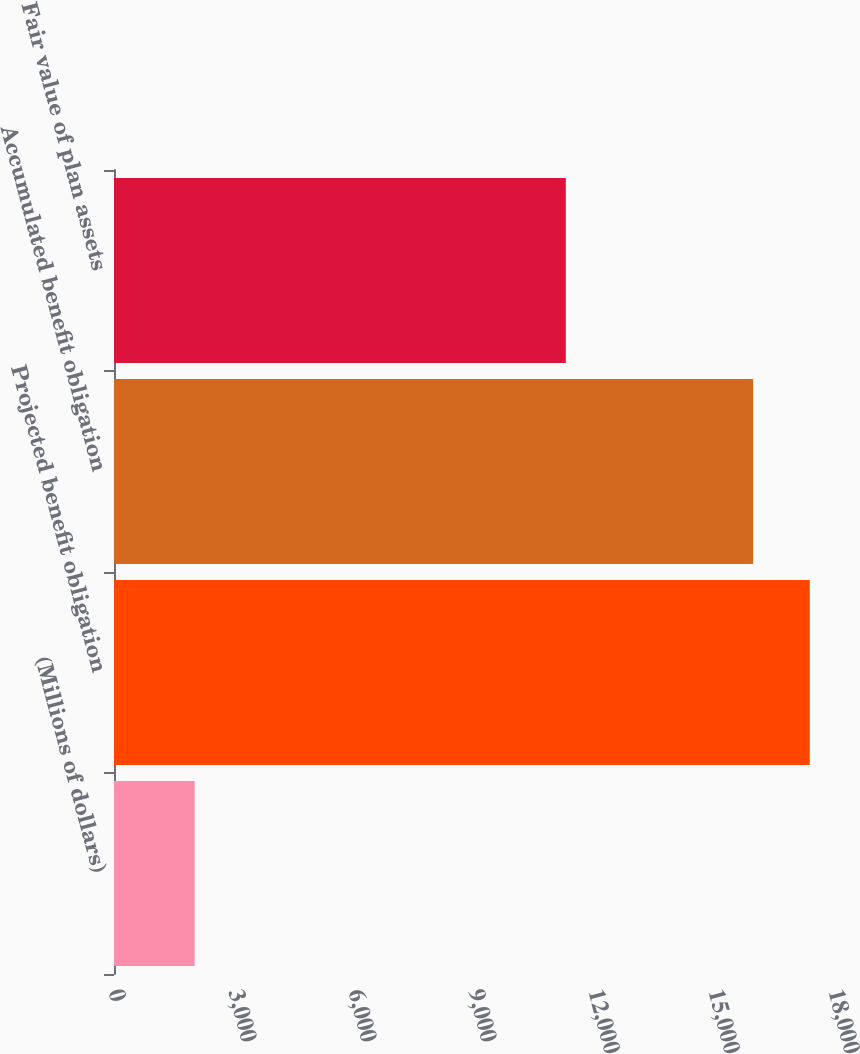Convert chart to OTSL. <chart><loc_0><loc_0><loc_500><loc_500><bar_chart><fcel>(Millions of dollars)<fcel>Projected benefit obligation<fcel>Accumulated benefit obligation<fcel>Fair value of plan assets<nl><fcel>2016<fcel>17393.7<fcel>15979<fcel>11295<nl></chart> 